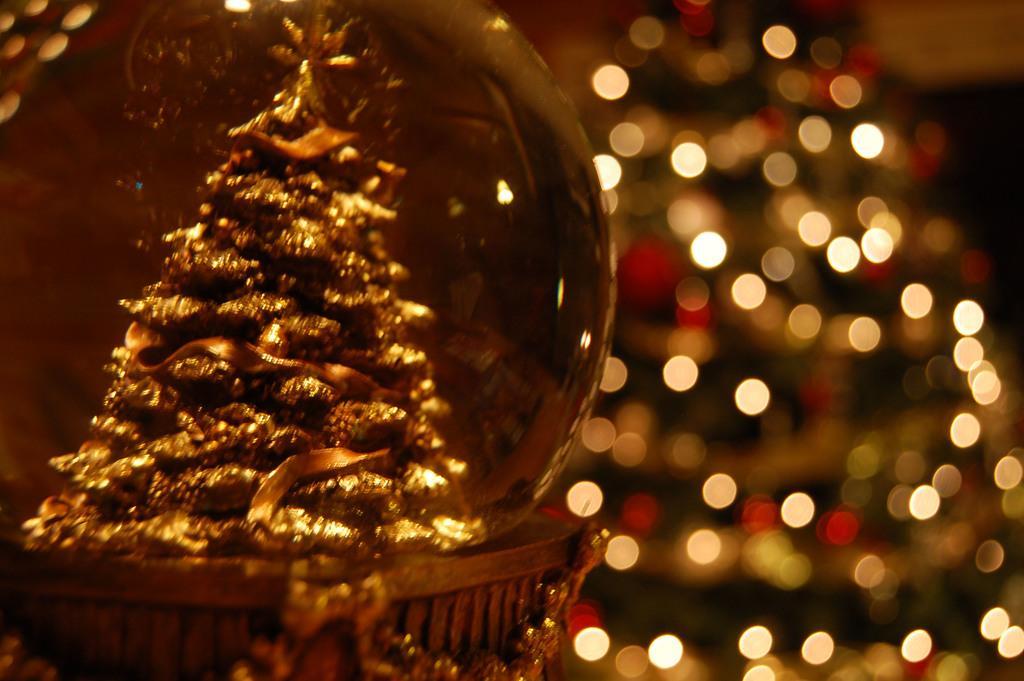How would you summarize this image in a sentence or two? Here in this picture we can see a gift item present, in that we can see some Christmas tree like structure present and this is viewed in a close up view and behind that we can see lights decorated over a place in blurry manner. 